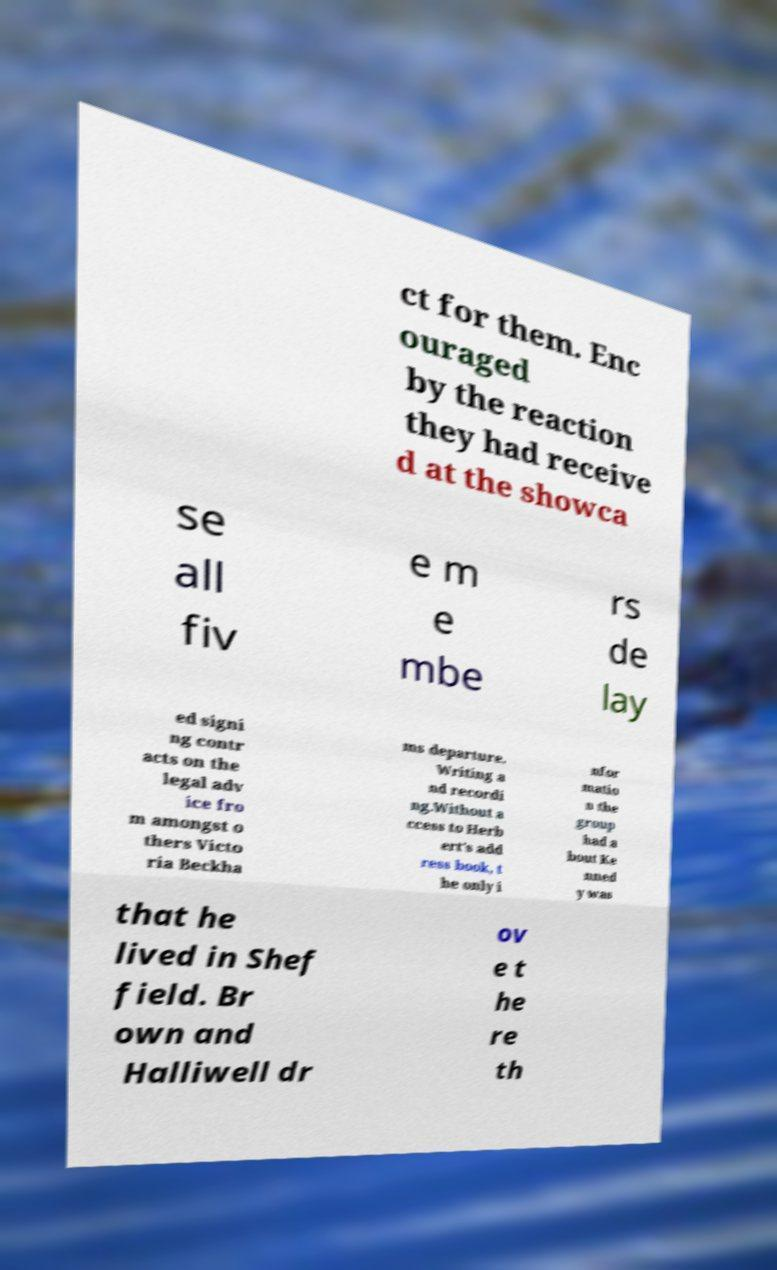Could you assist in decoding the text presented in this image and type it out clearly? ct for them. Enc ouraged by the reaction they had receive d at the showca se all fiv e m e mbe rs de lay ed signi ng contr acts on the legal adv ice fro m amongst o thers Victo ria Beckha ms departure. Writing a nd recordi ng.Without a ccess to Herb ert's add ress book, t he only i nfor matio n the group had a bout Ke nned y was that he lived in Shef field. Br own and Halliwell dr ov e t he re th 